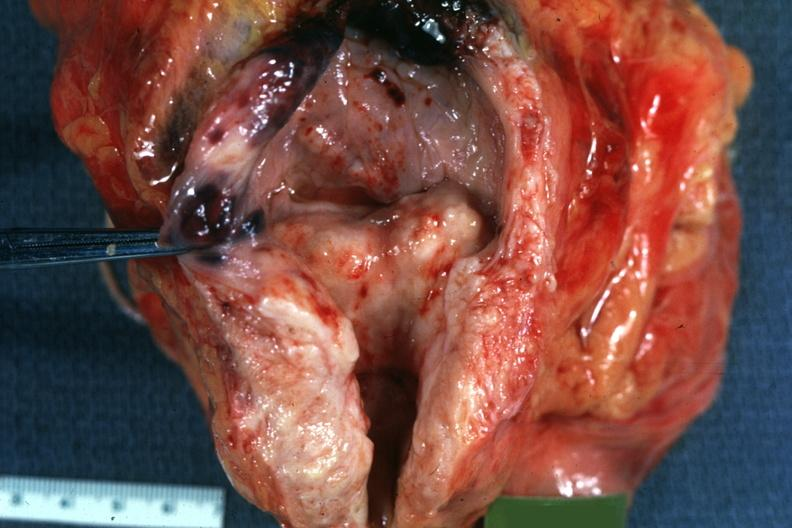what is present?
Answer the question using a single word or phrase. Hyperplasia 